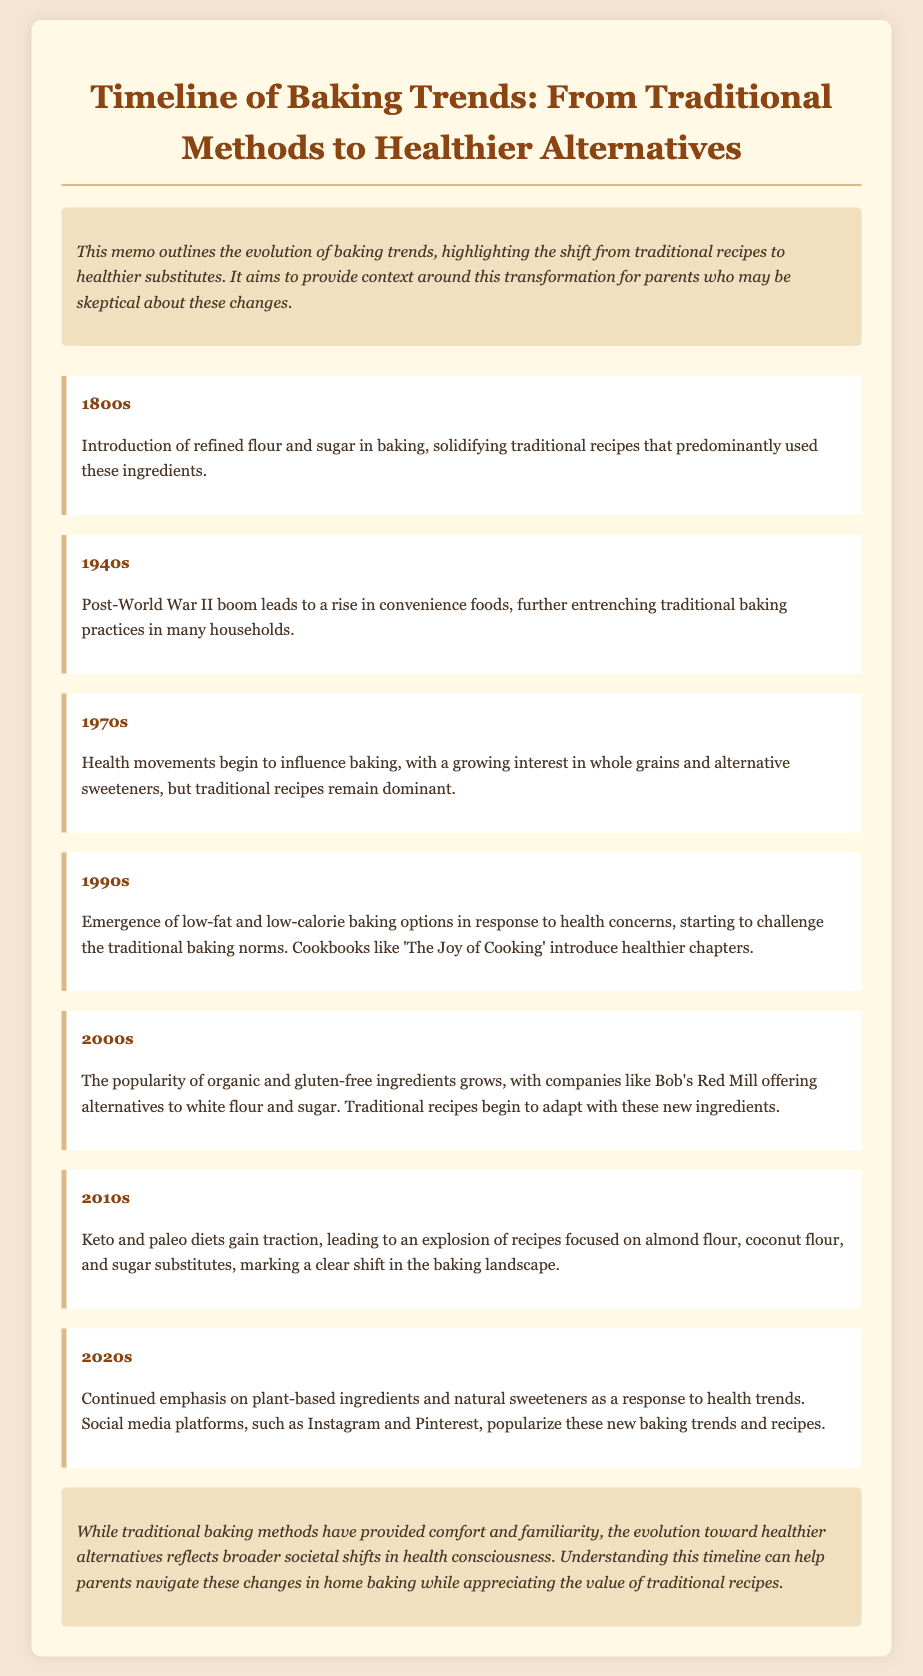What year marked the introduction of refined flour and sugar? The document states that the introduction of refined flour and sugar in baking occurred in the 1800s.
Answer: 1800s What baking trend began to emerge in the 1970s? The document mentions that health movements began to influence baking in the 1970s.
Answer: Whole grains and alternative sweeteners What cookbook was noted for introducing healthier chapters in the 1990s? According to the document, 'The Joy of Cooking' introduced healthier chapters in the 1990s.
Answer: The Joy of Cooking Which decade saw the rise of keto and paleo diets? The document indicates that the 2010s saw the rise of keto and paleo diets.
Answer: 2010s What trend in the 2020s highlighted plant-based ingredients? The document states that the 2020s emphasized plant-based ingredients as a health response.
Answer: Plant-based ingredients What were traditional baking methods largely characterized by in the 1800s? The document mentions that traditional baking methods were characterized by the use of refined flour and sugar.
Answer: Refined flour and sugar What is the primary purpose of the memo? The document indicates that the memo aims to provide context around the transformation from traditional recipes to healthier substitutes.
Answer: Provide context What societal shift is the conclusion addressing? The document concludes by addressing the shift in health consciousness influencing changes in baking.
Answer: Health consciousness 